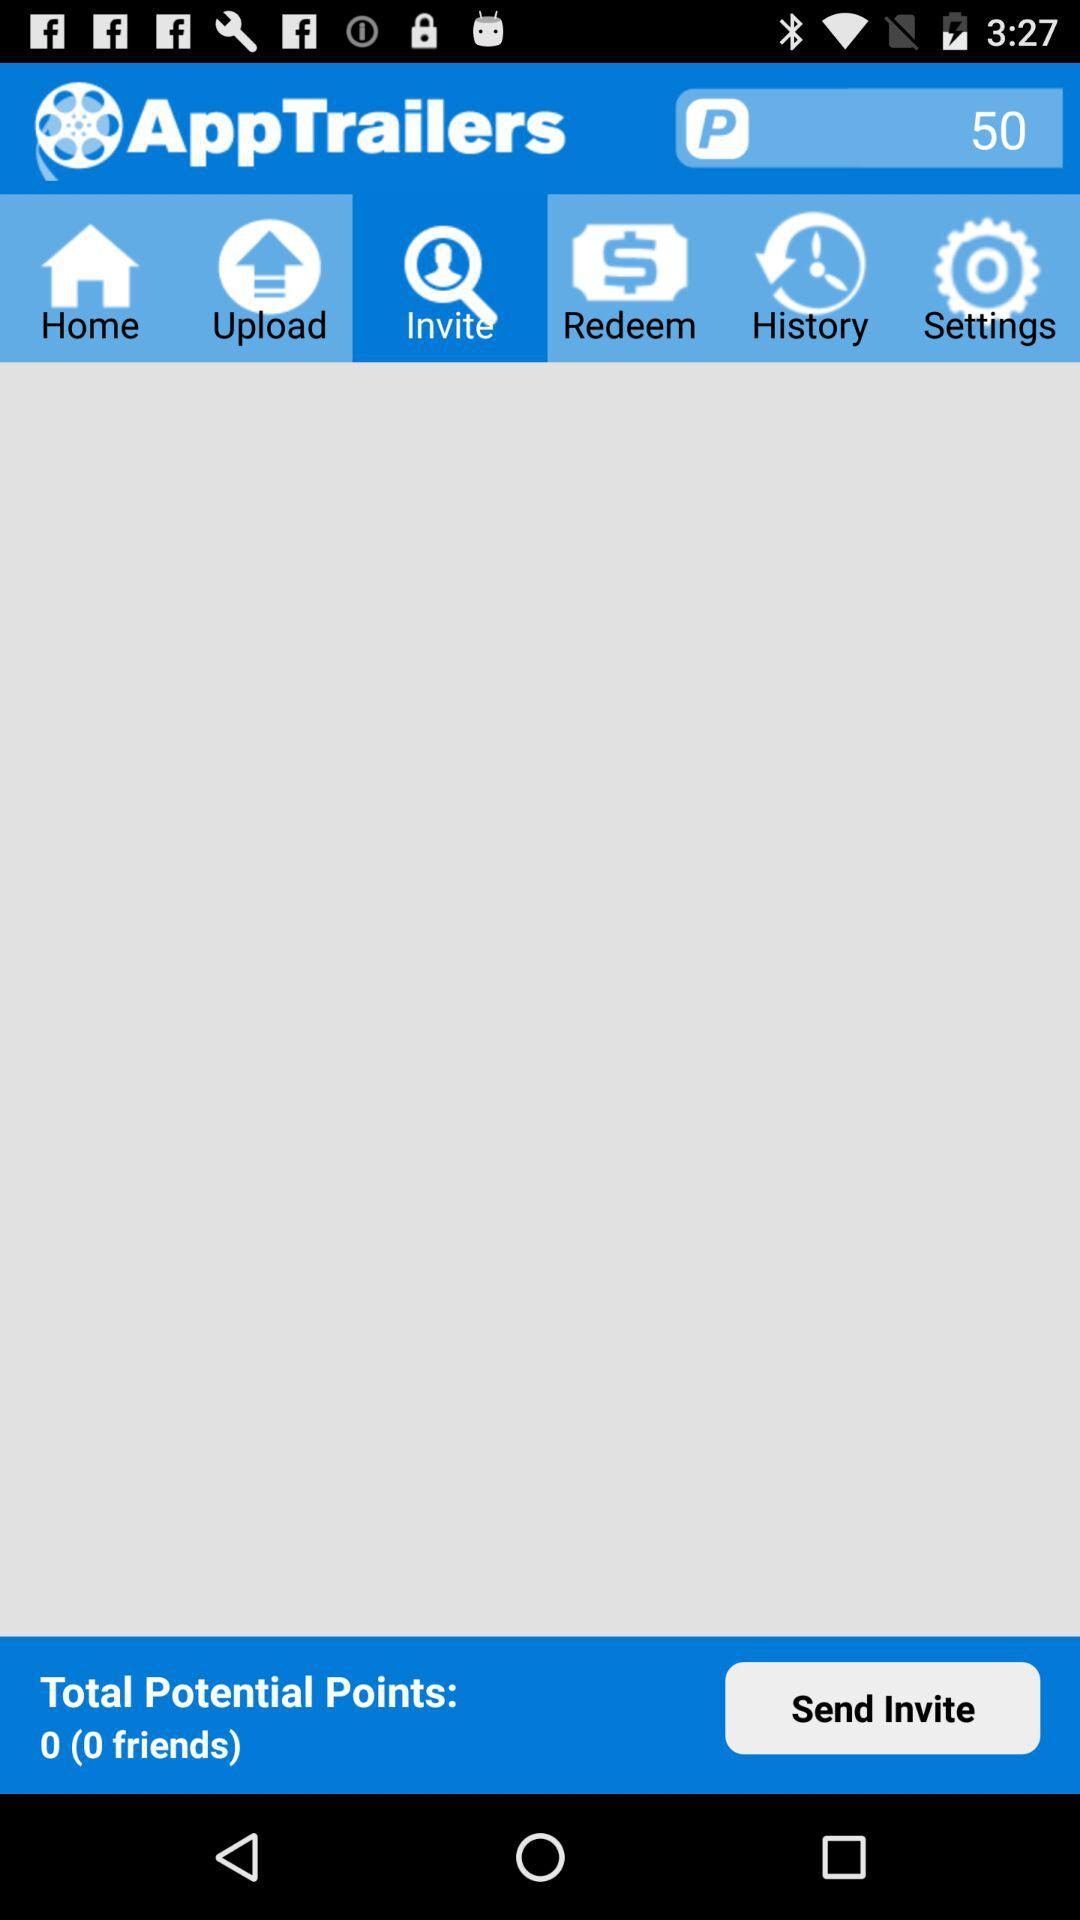What is the number of total potential points? The number of total potential points is 0. 